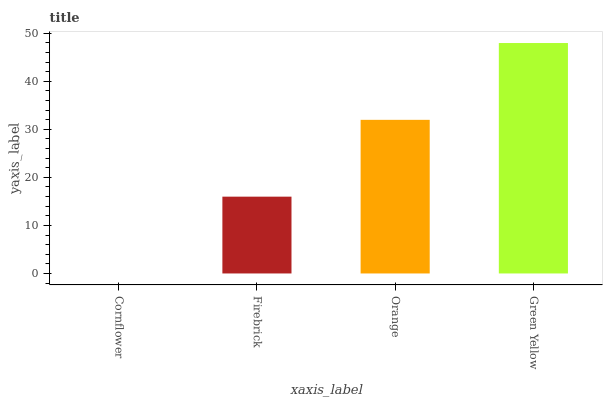Is Cornflower the minimum?
Answer yes or no. Yes. Is Green Yellow the maximum?
Answer yes or no. Yes. Is Firebrick the minimum?
Answer yes or no. No. Is Firebrick the maximum?
Answer yes or no. No. Is Firebrick greater than Cornflower?
Answer yes or no. Yes. Is Cornflower less than Firebrick?
Answer yes or no. Yes. Is Cornflower greater than Firebrick?
Answer yes or no. No. Is Firebrick less than Cornflower?
Answer yes or no. No. Is Orange the high median?
Answer yes or no. Yes. Is Firebrick the low median?
Answer yes or no. Yes. Is Firebrick the high median?
Answer yes or no. No. Is Cornflower the low median?
Answer yes or no. No. 